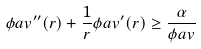<formula> <loc_0><loc_0><loc_500><loc_500>\phi a v ^ { \prime \prime } ( r ) + \frac { 1 } { r } \phi a v ^ { \prime } ( r ) \geq \frac { \alpha } { \phi a v }</formula> 